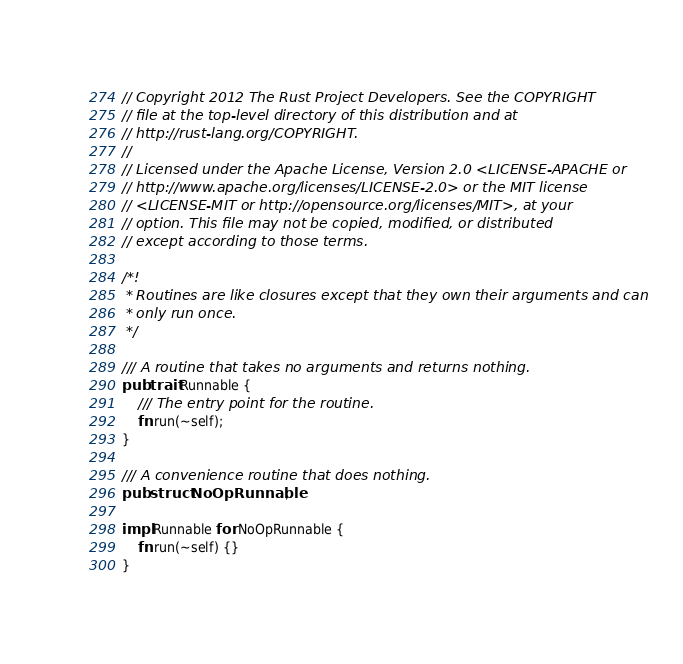<code> <loc_0><loc_0><loc_500><loc_500><_Rust_>// Copyright 2012 The Rust Project Developers. See the COPYRIGHT
// file at the top-level directory of this distribution and at
// http://rust-lang.org/COPYRIGHT.
//
// Licensed under the Apache License, Version 2.0 <LICENSE-APACHE or
// http://www.apache.org/licenses/LICENSE-2.0> or the MIT license
// <LICENSE-MIT or http://opensource.org/licenses/MIT>, at your
// option. This file may not be copied, modified, or distributed
// except according to those terms.

/*!
 * Routines are like closures except that they own their arguments and can
 * only run once.
 */

/// A routine that takes no arguments and returns nothing.
pub trait Runnable {
    /// The entry point for the routine.
    fn run(~self);
}

/// A convenience routine that does nothing.
pub struct NoOpRunnable;

impl Runnable for NoOpRunnable {
    fn run(~self) {}
}

</code> 